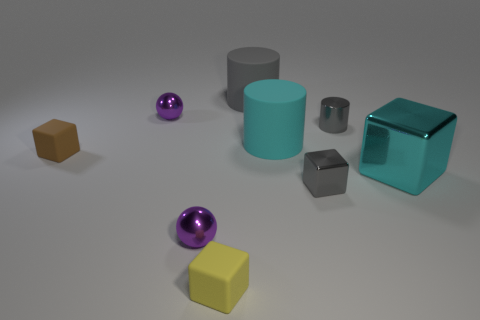What shape is the thing that is the same color as the big cube?
Ensure brevity in your answer.  Cylinder. Do the gray rubber object and the yellow matte object have the same shape?
Your answer should be very brief. No. How big is the cyan shiny block?
Offer a very short reply. Large. What number of purple metal spheres are the same size as the yellow rubber cube?
Your answer should be compact. 2. There is a gray thing that is right of the tiny gray cube; is its size the same as the purple metallic object in front of the brown block?
Provide a short and direct response. Yes. There is a large cyan object that is behind the brown rubber thing; what shape is it?
Make the answer very short. Cylinder. What material is the tiny purple thing that is behind the matte cube that is behind the yellow matte block?
Keep it short and to the point. Metal. Are there any big metallic objects of the same color as the tiny metal cylinder?
Provide a succinct answer. No. There is a cyan cylinder; does it have the same size as the rubber block behind the yellow matte object?
Give a very brief answer. No. How many big cyan shiny things are left of the brown thing that is to the left of the tiny sphere behind the brown matte block?
Offer a very short reply. 0. 